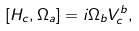Convert formula to latex. <formula><loc_0><loc_0><loc_500><loc_500>[ H _ { c } , \Omega _ { a } ] = i \Omega _ { b } V ^ { b } _ { c } ,</formula> 